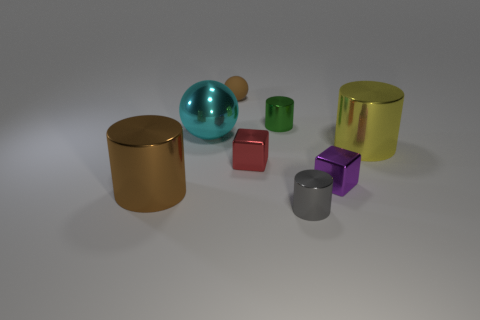Is there anything else that is the same material as the small brown thing?
Keep it short and to the point. No. Is the number of tiny shiny cylinders greater than the number of large shiny things?
Provide a short and direct response. No. Do the large yellow cylinder and the large brown cylinder have the same material?
Your answer should be very brief. Yes. What number of metallic objects are either small cylinders or big yellow things?
Keep it short and to the point. 3. There is a metal cylinder that is the same size as the green shiny thing; what is its color?
Provide a short and direct response. Gray. How many small matte things are the same shape as the green shiny object?
Your response must be concise. 0. How many balls are small blue objects or yellow metal things?
Your answer should be very brief. 0. There is a big thing on the right side of the gray thing; does it have the same shape as the metallic thing in front of the brown cylinder?
Keep it short and to the point. Yes. What is the material of the tiny brown ball?
Your answer should be compact. Rubber. What shape is the other thing that is the same color as the matte thing?
Make the answer very short. Cylinder. 